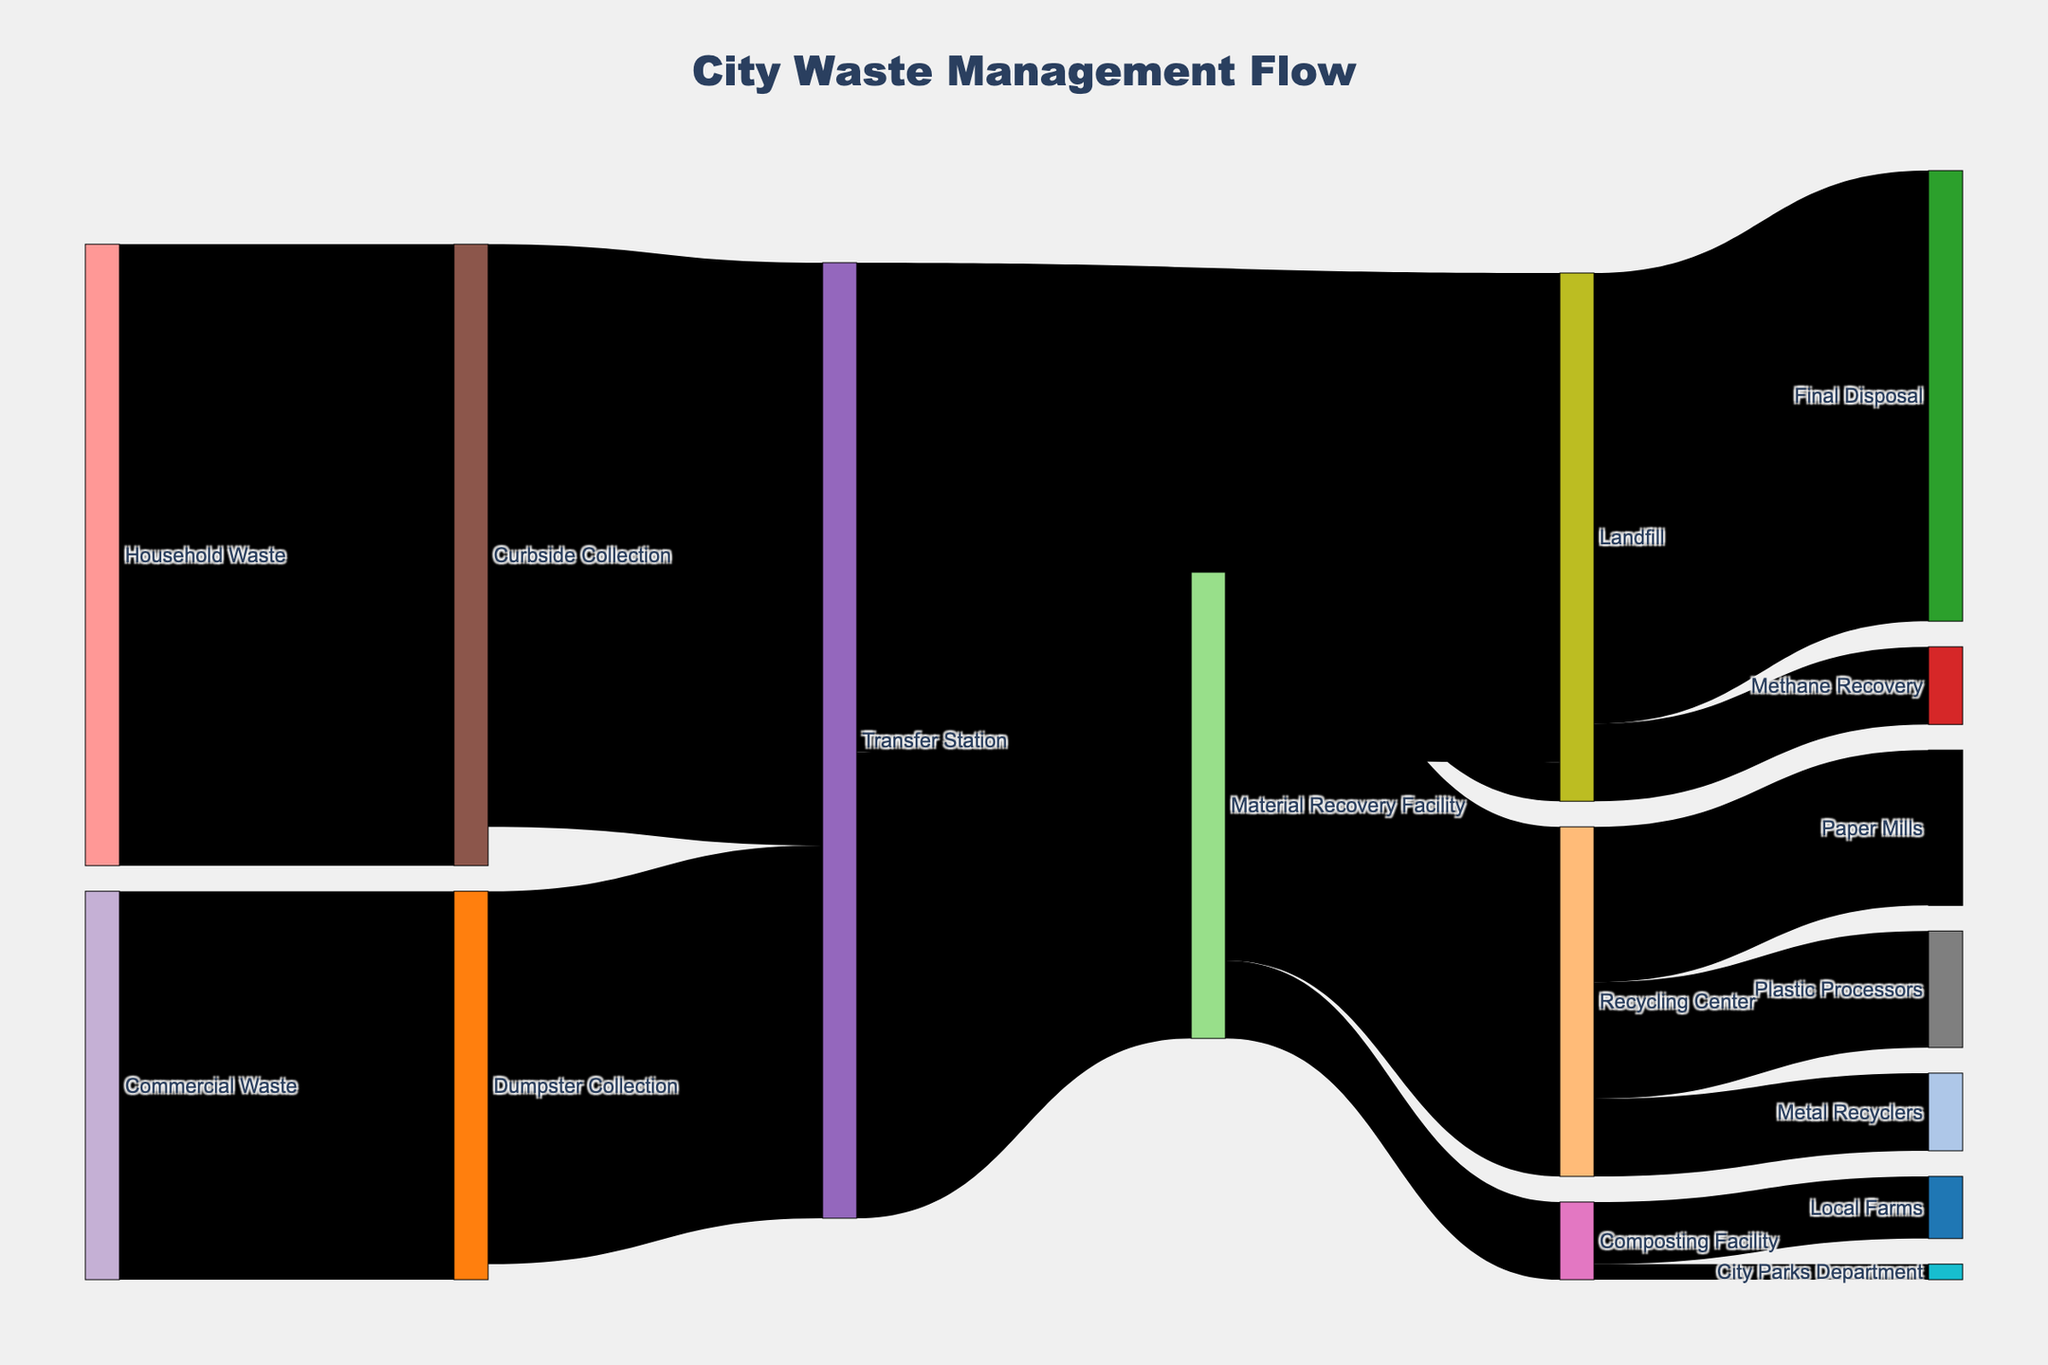How much waste is collected from households via curbside collection? The figure shows waste flows from various sources to targets, with values on each flow. Find the flow from "Household Waste" to "Curbside Collection," which is 8000 units.
Answer: 8000 units Which target receives the most waste directly from the transfer station? To determine this, look for the flows originating from the "Transfer Station" and compare their values. "Landfill" receives 6300 units, which is the highest.
Answer: Landfill How much total waste is processed by material recovery facilities? Waste is sent to the Material Recovery Facility from the Transfer Station (6000 units). The Material Recovery Facility then distributes it to different targets, such as Recycling Center, Composting Facility, and Landfill. However, the sum is just considering inflow: 6000 units.
Answer: 6000 units What percentage of the waste coming into the transfer station is directed towards landfills? First, sum the values directed to the Landfill from the Transfer Station (6300 units) and then the total waste to the Transfer Station (7500 + 4800 = 12300 units). Calculate the percentage: (6300 / 12300) * 100 ≈ 51.22%.
Answer: 51.22% Between composting facilities and material recovery facilities, which reallocates more waste to other places? The figure shows flows. The Material Recovery Facility directs 4500 to Recycling Center, 1000 to Composting Facility, and 500 to Landfill (6000 units). Composting Facility directs 800 to Local Farms and 200 to City Parks Department (1000 units). Material Recovery Facility reallocates more.
Answer: Material Recovery Facility Which flow to the landfill has the smallest value? Check the flows targeting the Landfill. From the Transfer Station: 6300 units; from the Material Recovery Facility: 500 units. The smallest is from the Material Recovery Facility.
Answer: 500 units How much waste is ultimately recycled by paper mills, plastic processors, and metal recyclers combined? The flows from the Recycling Center to Paper Mills (2000 units), Plastic Processors (1500 units), and Metal Recyclers (1000 units) should be summed: 2000 + 1500 + 1000 = 4500 units.
Answer: 4500 units From the households' curbside collection, how much waste makes it to the Transfer Station? The flow from "Curbside Collection" to the "Transfer Station" shows 7500 units of waste.
Answer: 7500 units Is there more waste going into recycling or final disposal from the landfill? From the Landfill to Methane Recovery (1000 units) and Final Disposal (5800 units), total reuse is 1000 units and final disposal is 5800 units. Final Disposal receives more.
Answer: Final Disposal Which is greater: waste sent from commercial waste to dumpster collection or from the transfer station to recycling center? Check the flows: Commercial Waste to Dumpster Collection is 5000 units, Transfer Station to Material Recovery Facility to Recycling Center is 6000 units to 4500 units. Direct comparison: 5000 vs 4500 units.
Answer: Commercial Waste to Dumpster Collection 